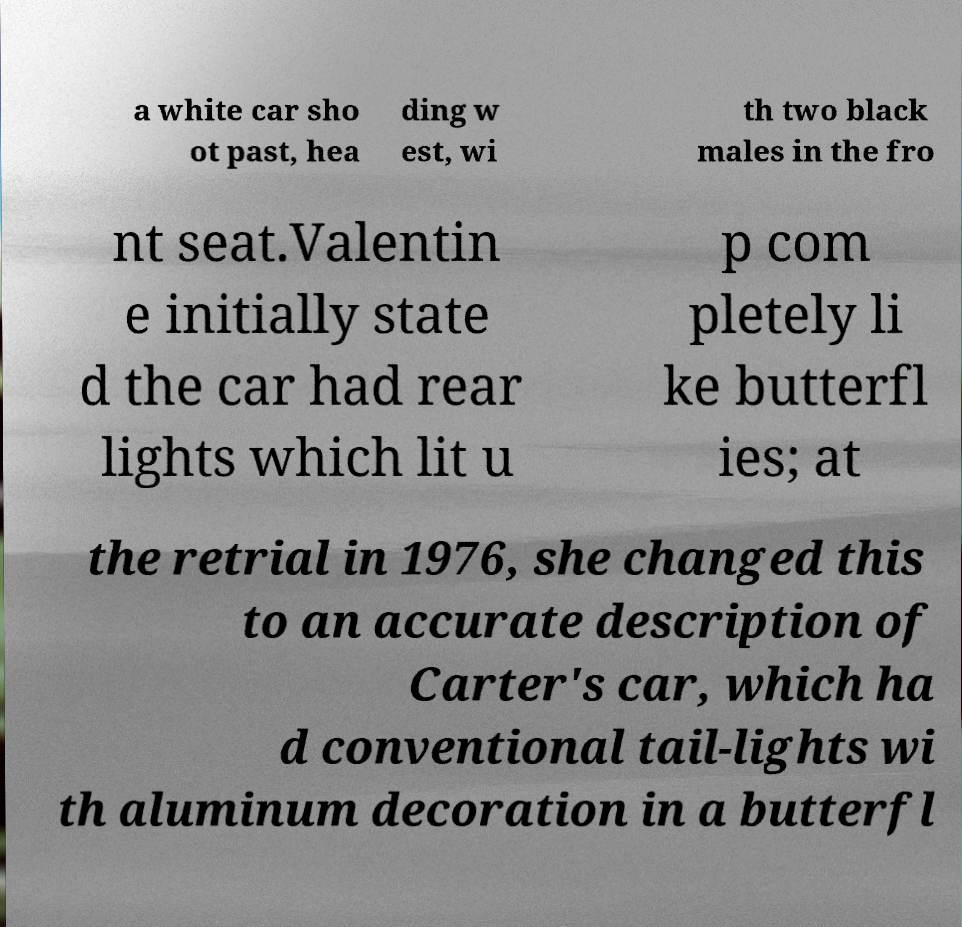For documentation purposes, I need the text within this image transcribed. Could you provide that? a white car sho ot past, hea ding w est, wi th two black males in the fro nt seat.Valentin e initially state d the car had rear lights which lit u p com pletely li ke butterfl ies; at the retrial in 1976, she changed this to an accurate description of Carter's car, which ha d conventional tail-lights wi th aluminum decoration in a butterfl 